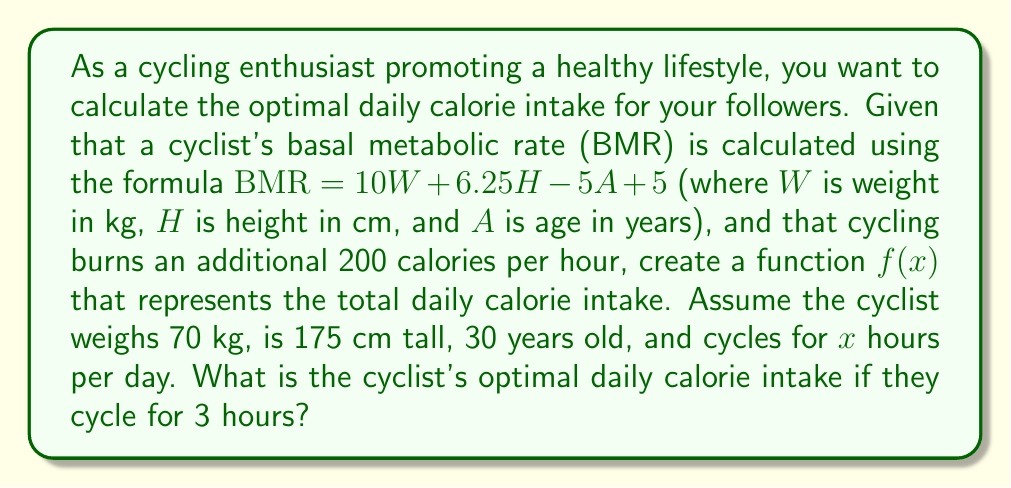Could you help me with this problem? Let's approach this step-by-step:

1) First, we need to calculate the BMR using the given formula:
   $BMR = 10W + 6.25H - 5A + 5$
   $BMR = 10(70) + 6.25(175) - 5(30) + 5$
   $BMR = 700 + 1093.75 - 150 + 5$
   $BMR = 1648.75$ calories

2) Now, we need to create a function $f(x)$ that represents the total daily calorie intake:
   $f(x) = BMR + 200x$
   Where x is the number of hours spent cycling.

3) Substituting the BMR we calculated:
   $f(x) = 1648.75 + 200x$

4) To find the optimal daily calorie intake for 3 hours of cycling, we substitute x = 3:
   $f(3) = 1648.75 + 200(3)$
   $f(3) = 1648.75 + 600$
   $f(3) = 2248.75$ calories

Therefore, the cyclist's optimal daily calorie intake when cycling for 3 hours is 2248.75 calories.
Answer: 2248.75 calories 